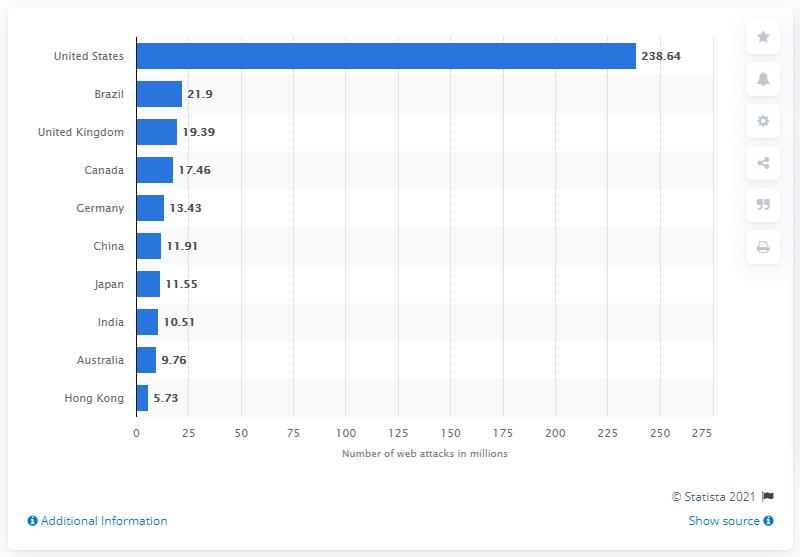Highlight a few significant elements in this photo. According to data, 238.6 million cyber attacks were targeted towards the United States. In the fourth quarter of 2017, 21.9 web application attacks were directed towards Brazil. 